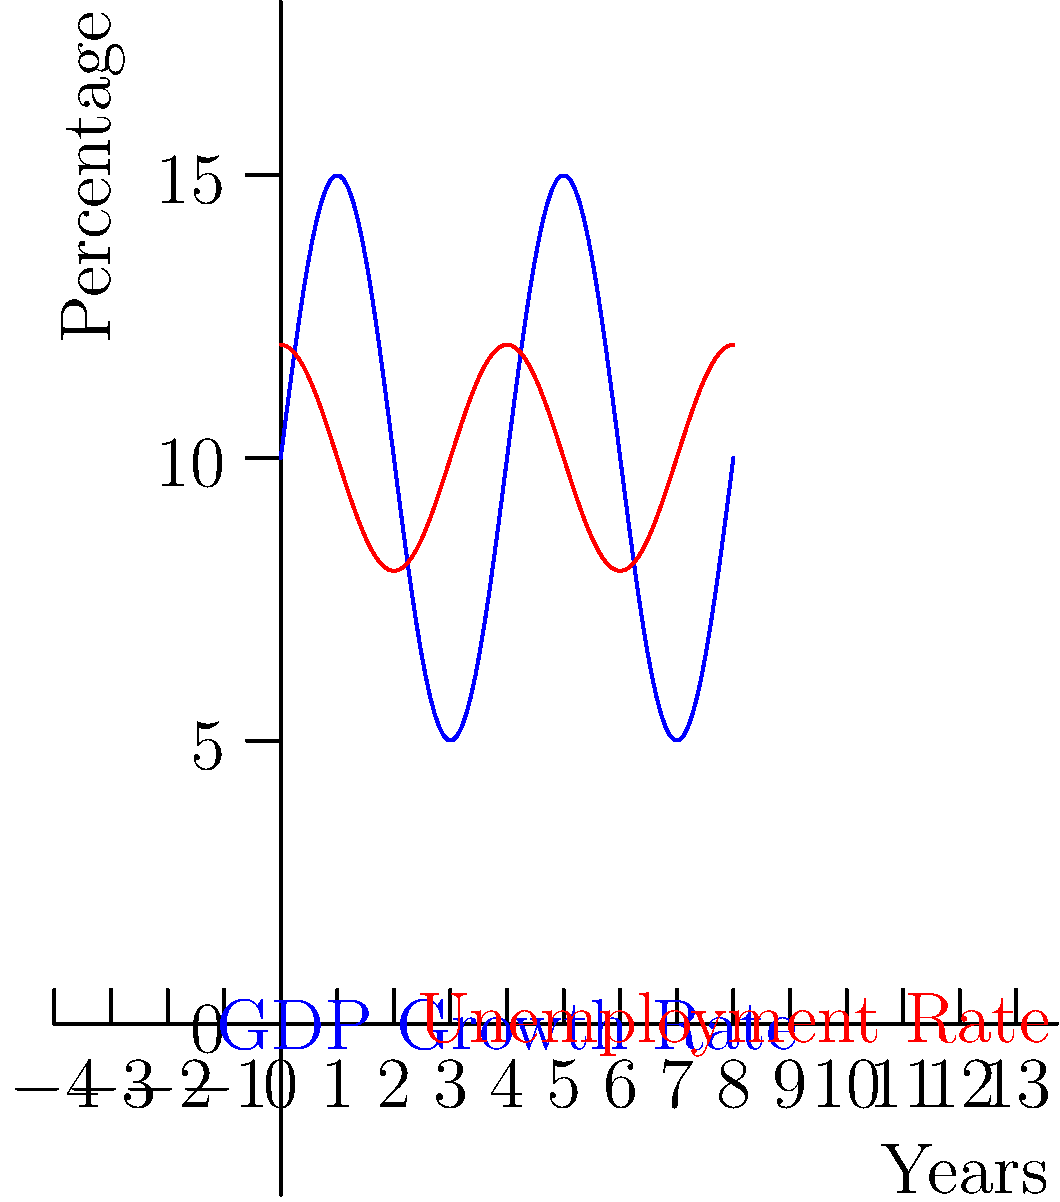As a government official, you're analyzing economic cycles using trigonometric functions. The graph shows the GDP growth rate and unemployment rate over an 8-year period. The GDP growth rate is modeled by the function $f(x) = 5\sin(\frac{\pi x}{2}) + 10$ and the unemployment rate by $g(x) = 2\cos(\frac{\pi x}{2}) + 10$, where $x$ represents years. What is the period of these economic cycles, and at what year do the GDP growth rate and unemployment rate intersect for the first time in the given interval? To solve this problem, let's follow these steps:

1) Period of the cycles:
   The general form of a sine or cosine function is $a\sin(bx)$ or $a\cos(bx)$, where the period is given by $\frac{2\pi}{|b|}$.
   In both functions, $b = \frac{\pi}{2}$
   So, the period = $\frac{2\pi}{|\frac{\pi}{2}|} = 4$ years

2) Intersection point:
   To find where the functions intersect, we set them equal:
   $5\sin(\frac{\pi x}{2}) + 10 = 2\cos(\frac{\pi x}{2}) + 10$

3) Simplify:
   $5\sin(\frac{\pi x}{2}) = 2\cos(\frac{\pi x}{2})$

4) Divide both sides by $\cos(\frac{\pi x}{2})$:
   $5\tan(\frac{\pi x}{2}) = 2$

5) Solve for $x$:
   $\tan(\frac{\pi x}{2}) = \frac{2}{5}$
   $\frac{\pi x}{2} = \arctan(\frac{2}{5})$
   $x = \frac{2}{\pi}\arctan(\frac{2}{5}) \approx 0.81$ years

6) The first intersection in the given interval occurs at approximately 0.81 years, which is about 9.7 months after the start of the cycle.
Answer: Period: 4 years; First intersection: 0.81 years 